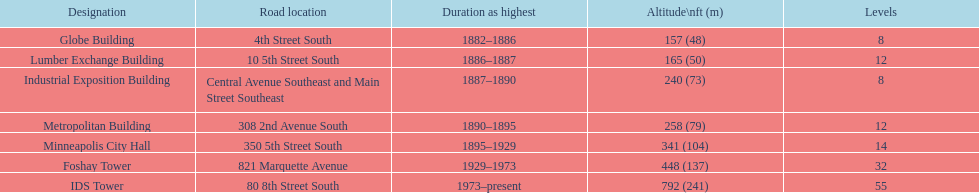Which building has 8 floors and is 240 ft tall? Industrial Exposition Building. 